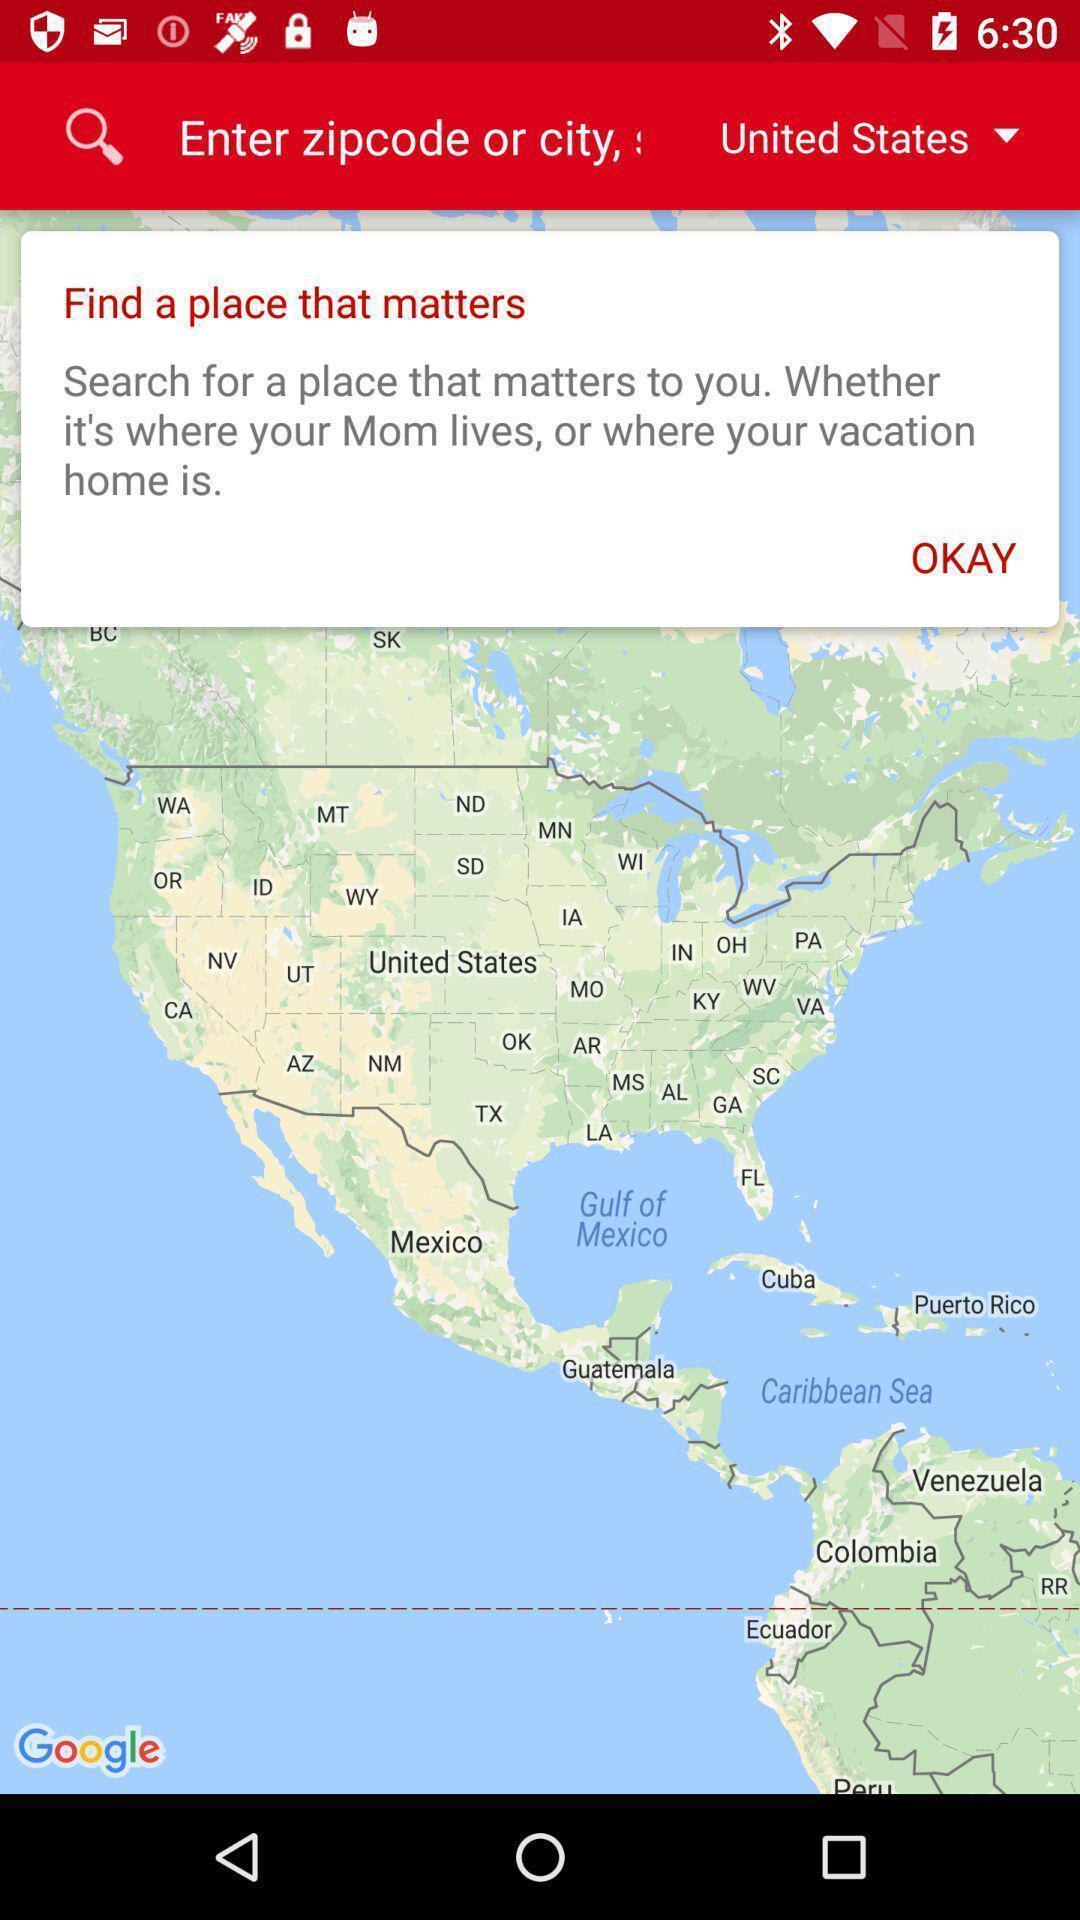Describe the content in this image. Zip code or city in the map. 